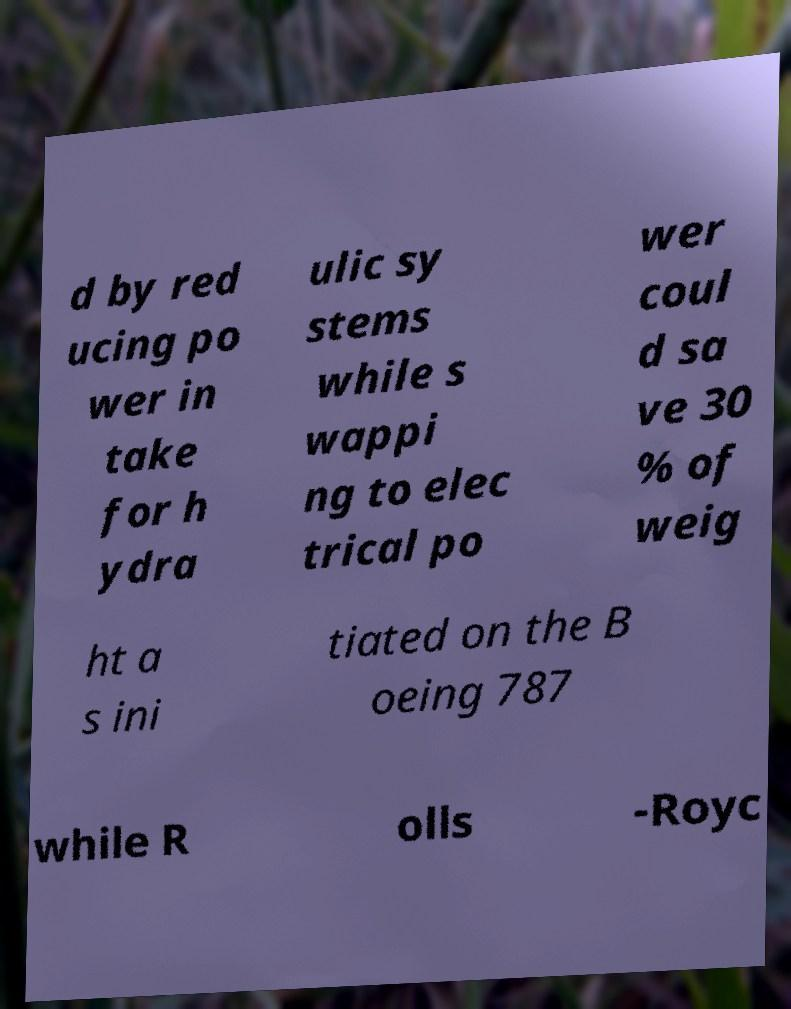For documentation purposes, I need the text within this image transcribed. Could you provide that? d by red ucing po wer in take for h ydra ulic sy stems while s wappi ng to elec trical po wer coul d sa ve 30 % of weig ht a s ini tiated on the B oeing 787 while R olls -Royc 